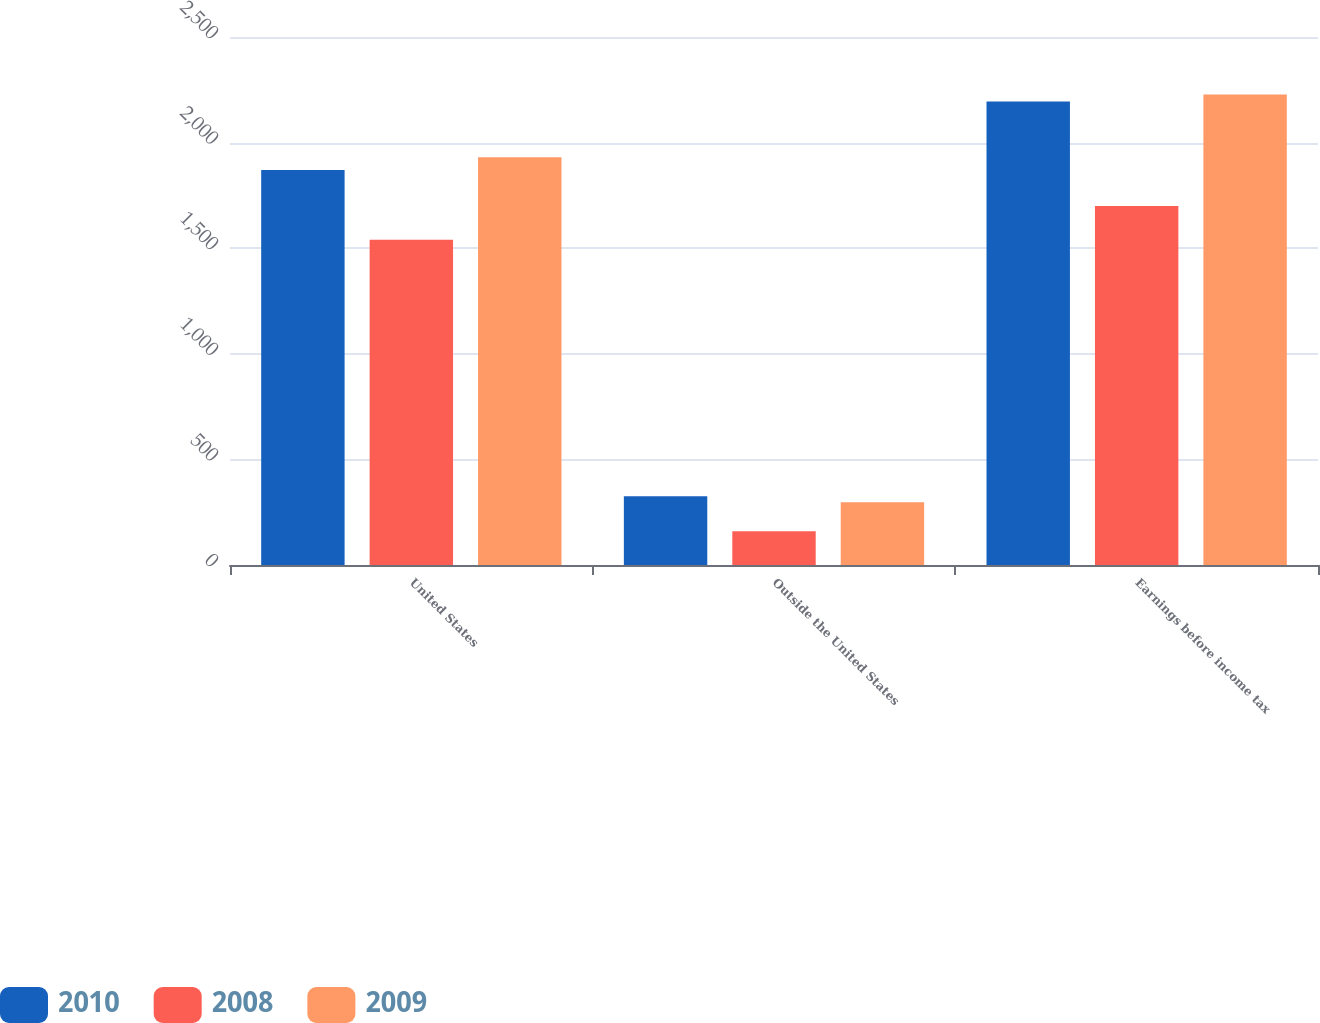<chart> <loc_0><loc_0><loc_500><loc_500><stacked_bar_chart><ecel><fcel>United States<fcel>Outside the United States<fcel>Earnings before income tax<nl><fcel>2010<fcel>1870<fcel>325<fcel>2195<nl><fcel>2008<fcel>1540<fcel>160<fcel>1700<nl><fcel>2009<fcel>1931<fcel>297<fcel>2228<nl></chart> 